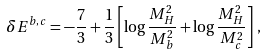Convert formula to latex. <formula><loc_0><loc_0><loc_500><loc_500>\delta E ^ { b , c } = - \frac { 7 } { 3 } + \frac { 1 } { 3 } \left [ \log \frac { M _ { H } ^ { 2 } } { M _ { b } ^ { 2 } } + \log \frac { M _ { H } ^ { 2 } } { M _ { c } ^ { 2 } } \right ] \, ,</formula> 